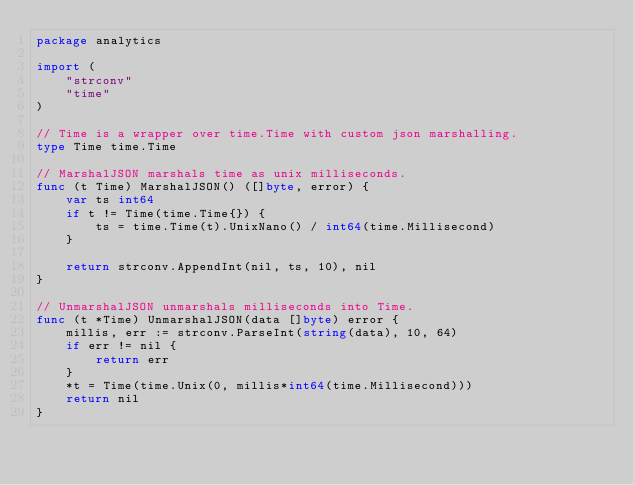<code> <loc_0><loc_0><loc_500><loc_500><_Go_>package analytics

import (
	"strconv"
	"time"
)

// Time is a wrapper over time.Time with custom json marshalling.
type Time time.Time

// MarshalJSON marshals time as unix milliseconds.
func (t Time) MarshalJSON() ([]byte, error) {
	var ts int64
	if t != Time(time.Time{}) {
		ts = time.Time(t).UnixNano() / int64(time.Millisecond)
	}

	return strconv.AppendInt(nil, ts, 10), nil
}

// UnmarshalJSON unmarshals milliseconds into Time.
func (t *Time) UnmarshalJSON(data []byte) error {
	millis, err := strconv.ParseInt(string(data), 10, 64)
	if err != nil {
		return err
	}
	*t = Time(time.Unix(0, millis*int64(time.Millisecond)))
	return nil
}
</code> 